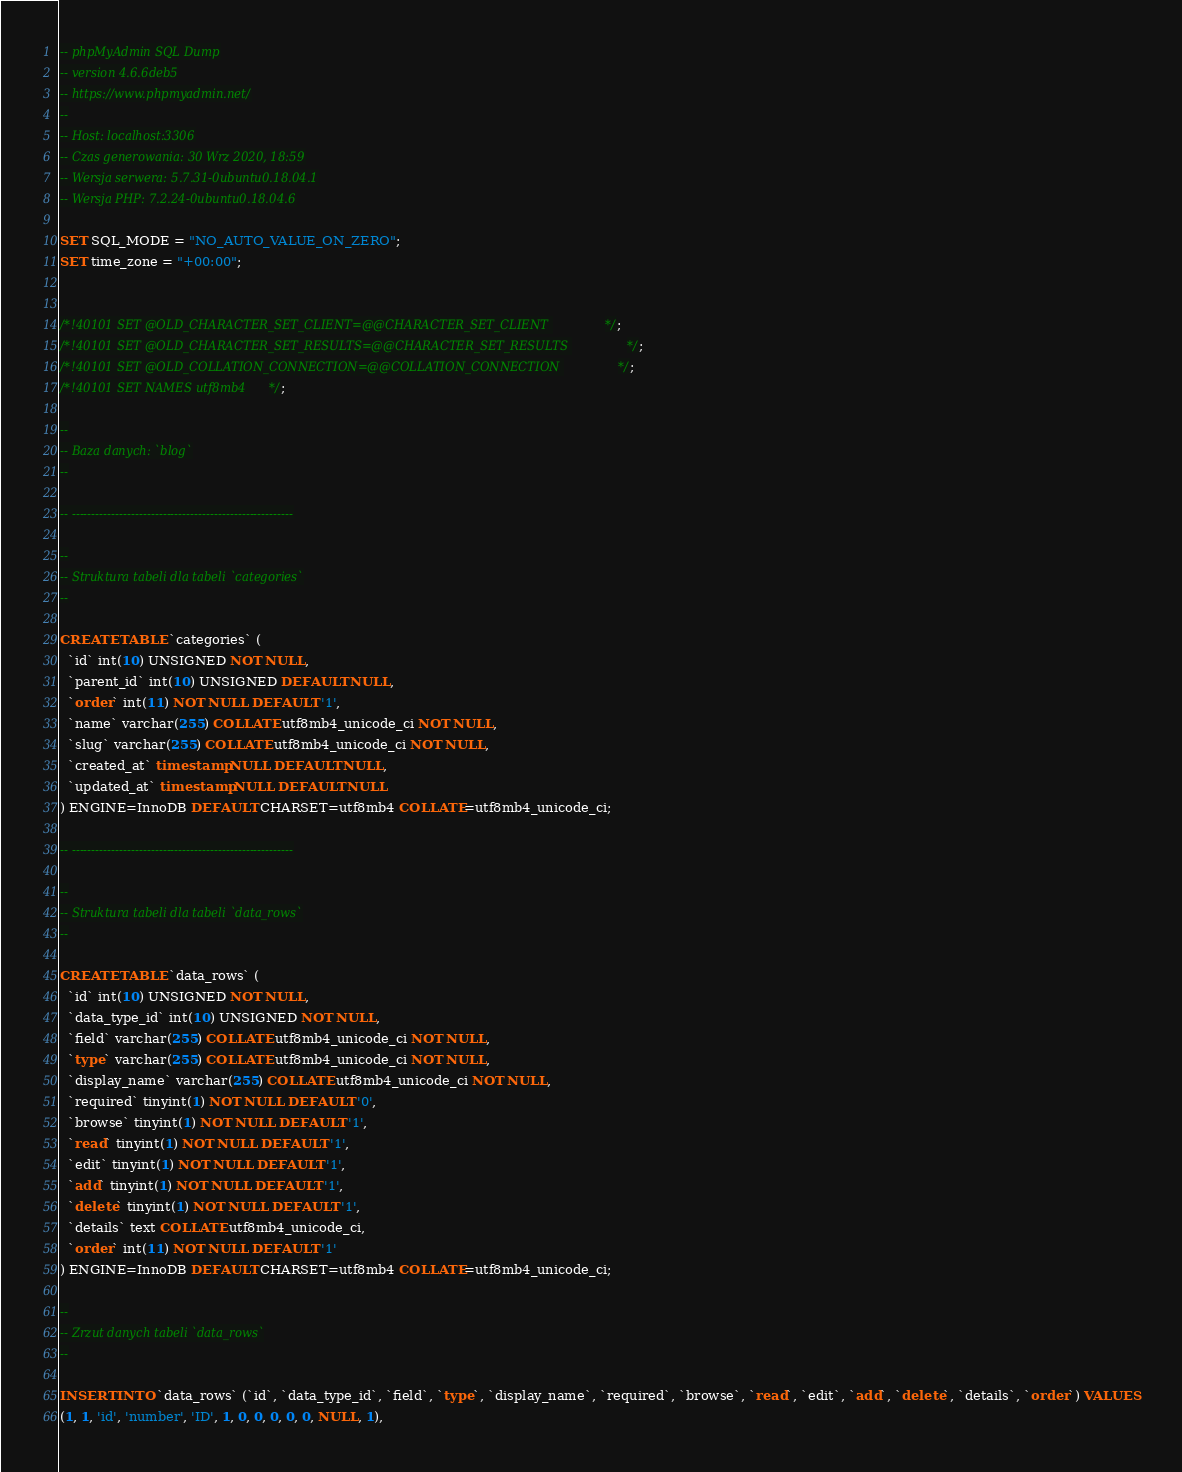Convert code to text. <code><loc_0><loc_0><loc_500><loc_500><_SQL_>-- phpMyAdmin SQL Dump
-- version 4.6.6deb5
-- https://www.phpmyadmin.net/
--
-- Host: localhost:3306
-- Czas generowania: 30 Wrz 2020, 18:59
-- Wersja serwera: 5.7.31-0ubuntu0.18.04.1
-- Wersja PHP: 7.2.24-0ubuntu0.18.04.6

SET SQL_MODE = "NO_AUTO_VALUE_ON_ZERO";
SET time_zone = "+00:00";


/*!40101 SET @OLD_CHARACTER_SET_CLIENT=@@CHARACTER_SET_CLIENT */;
/*!40101 SET @OLD_CHARACTER_SET_RESULTS=@@CHARACTER_SET_RESULTS */;
/*!40101 SET @OLD_COLLATION_CONNECTION=@@COLLATION_CONNECTION */;
/*!40101 SET NAMES utf8mb4 */;

--
-- Baza danych: `blog`
--

-- --------------------------------------------------------

--
-- Struktura tabeli dla tabeli `categories`
--

CREATE TABLE `categories` (
  `id` int(10) UNSIGNED NOT NULL,
  `parent_id` int(10) UNSIGNED DEFAULT NULL,
  `order` int(11) NOT NULL DEFAULT '1',
  `name` varchar(255) COLLATE utf8mb4_unicode_ci NOT NULL,
  `slug` varchar(255) COLLATE utf8mb4_unicode_ci NOT NULL,
  `created_at` timestamp NULL DEFAULT NULL,
  `updated_at` timestamp NULL DEFAULT NULL
) ENGINE=InnoDB DEFAULT CHARSET=utf8mb4 COLLATE=utf8mb4_unicode_ci;

-- --------------------------------------------------------

--
-- Struktura tabeli dla tabeli `data_rows`
--

CREATE TABLE `data_rows` (
  `id` int(10) UNSIGNED NOT NULL,
  `data_type_id` int(10) UNSIGNED NOT NULL,
  `field` varchar(255) COLLATE utf8mb4_unicode_ci NOT NULL,
  `type` varchar(255) COLLATE utf8mb4_unicode_ci NOT NULL,
  `display_name` varchar(255) COLLATE utf8mb4_unicode_ci NOT NULL,
  `required` tinyint(1) NOT NULL DEFAULT '0',
  `browse` tinyint(1) NOT NULL DEFAULT '1',
  `read` tinyint(1) NOT NULL DEFAULT '1',
  `edit` tinyint(1) NOT NULL DEFAULT '1',
  `add` tinyint(1) NOT NULL DEFAULT '1',
  `delete` tinyint(1) NOT NULL DEFAULT '1',
  `details` text COLLATE utf8mb4_unicode_ci,
  `order` int(11) NOT NULL DEFAULT '1'
) ENGINE=InnoDB DEFAULT CHARSET=utf8mb4 COLLATE=utf8mb4_unicode_ci;

--
-- Zrzut danych tabeli `data_rows`
--

INSERT INTO `data_rows` (`id`, `data_type_id`, `field`, `type`, `display_name`, `required`, `browse`, `read`, `edit`, `add`, `delete`, `details`, `order`) VALUES
(1, 1, 'id', 'number', 'ID', 1, 0, 0, 0, 0, 0, NULL, 1),</code> 